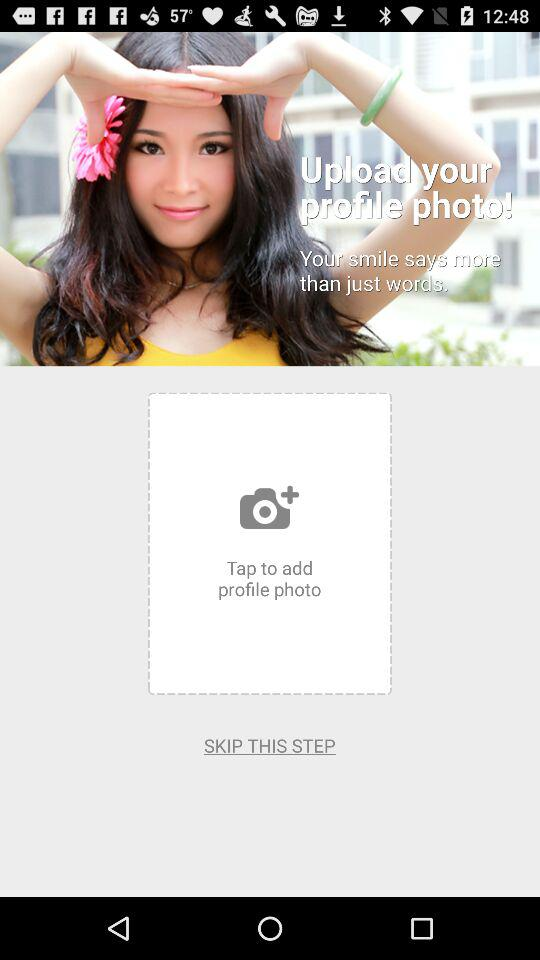Can we skip the photo upload step? You can skip the photo upload step. 